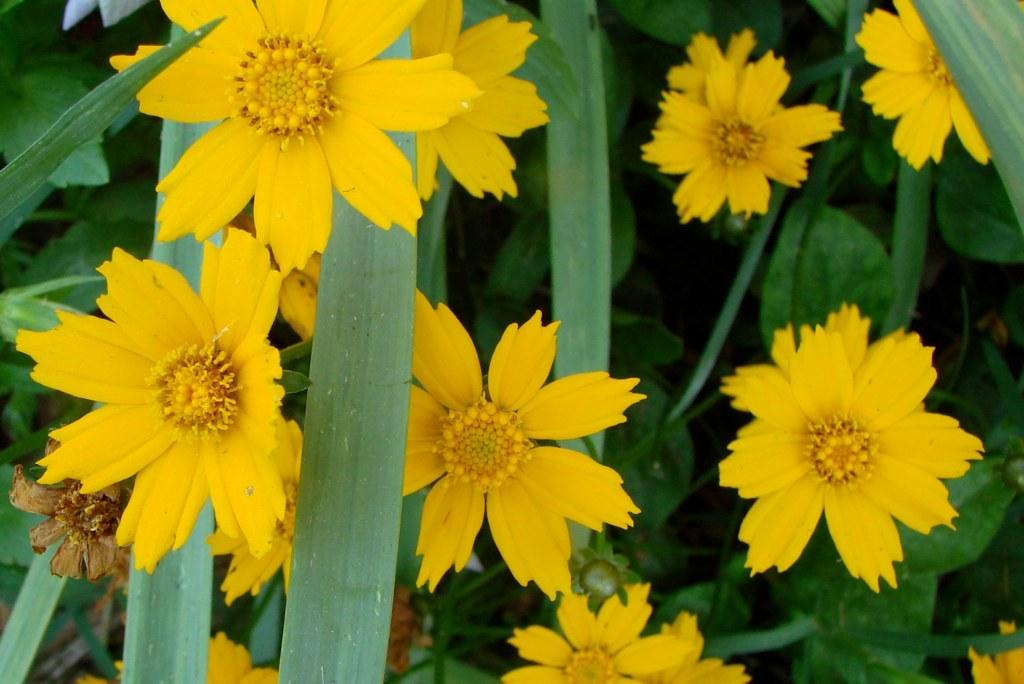What type of flowers are present in the image? The image contains yellow color flowers. What else can be seen in the image besides the flowers? The image contains leaves. What type of tray is used to hold the flowers in the image? There is no tray present in the image; the flowers are not in a tray. 